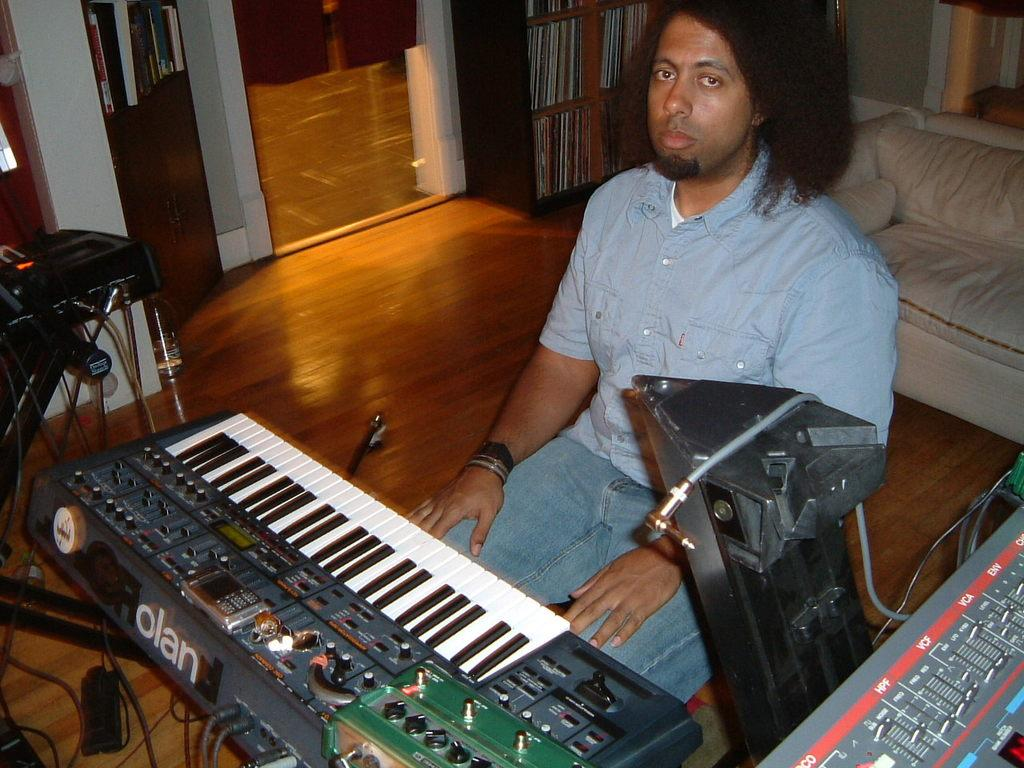What is the person in the image doing? The person is sitting on a chair in the image. What musical instrument can be seen in the image? There is a piano in the image. Where are the books located in the image? The books are in racks in the image. What type of furniture is present in the image besides the chair? There is a couch in the image. Can you describe any other objects visible in the image? There are some other objects in the image, but their specific details are not mentioned in the provided facts. How does the person in the image use their knowledge to skate on the front of the couch? There is no mention of skating or the front of the couch in the provided facts. 